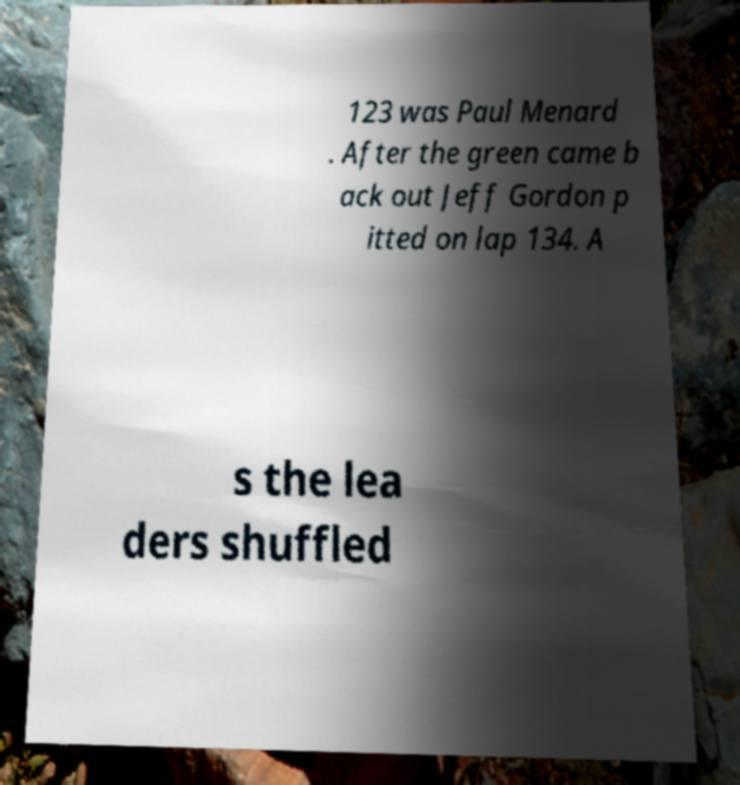There's text embedded in this image that I need extracted. Can you transcribe it verbatim? 123 was Paul Menard . After the green came b ack out Jeff Gordon p itted on lap 134. A s the lea ders shuffled 